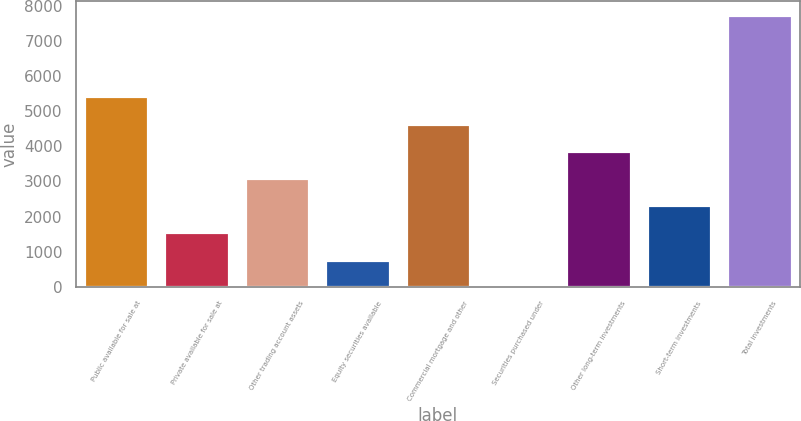Convert chart to OTSL. <chart><loc_0><loc_0><loc_500><loc_500><bar_chart><fcel>Public available for sale at<fcel>Private available for sale at<fcel>Other trading account assets<fcel>Equity securities available<fcel>Commercial mortgage and other<fcel>Securities purchased under<fcel>Other long-term investments<fcel>Short-term investments<fcel>Total investments<nl><fcel>5417.7<fcel>1552.2<fcel>3098.4<fcel>779.1<fcel>4644.6<fcel>6<fcel>3871.5<fcel>2325.3<fcel>7737<nl></chart> 